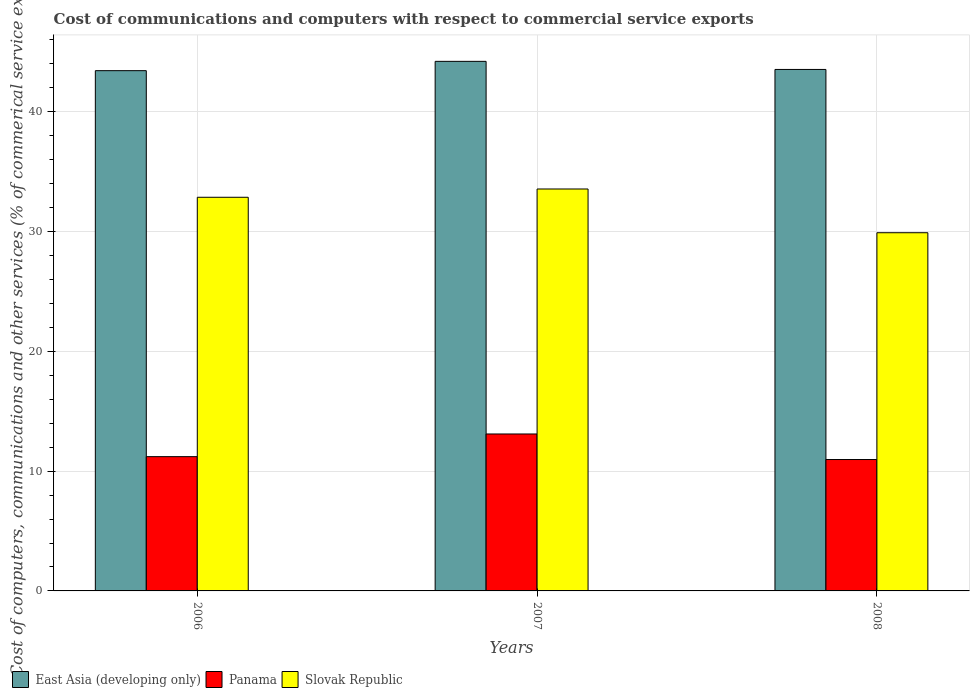Are the number of bars per tick equal to the number of legend labels?
Your answer should be compact. Yes. Are the number of bars on each tick of the X-axis equal?
Provide a short and direct response. Yes. How many bars are there on the 3rd tick from the left?
Provide a succinct answer. 3. In how many cases, is the number of bars for a given year not equal to the number of legend labels?
Give a very brief answer. 0. What is the cost of communications and computers in Panama in 2008?
Offer a terse response. 10.97. Across all years, what is the maximum cost of communications and computers in Panama?
Offer a very short reply. 13.1. Across all years, what is the minimum cost of communications and computers in East Asia (developing only)?
Provide a succinct answer. 43.43. What is the total cost of communications and computers in Slovak Republic in the graph?
Make the answer very short. 96.31. What is the difference between the cost of communications and computers in Slovak Republic in 2006 and that in 2008?
Ensure brevity in your answer.  2.96. What is the difference between the cost of communications and computers in Slovak Republic in 2007 and the cost of communications and computers in East Asia (developing only) in 2008?
Your response must be concise. -9.98. What is the average cost of communications and computers in East Asia (developing only) per year?
Offer a very short reply. 43.72. In the year 2007, what is the difference between the cost of communications and computers in Slovak Republic and cost of communications and computers in Panama?
Make the answer very short. 20.45. What is the ratio of the cost of communications and computers in East Asia (developing only) in 2006 to that in 2007?
Make the answer very short. 0.98. Is the cost of communications and computers in Panama in 2006 less than that in 2007?
Ensure brevity in your answer.  Yes. What is the difference between the highest and the second highest cost of communications and computers in East Asia (developing only)?
Offer a very short reply. 0.67. What is the difference between the highest and the lowest cost of communications and computers in Panama?
Offer a terse response. 2.13. What does the 3rd bar from the left in 2006 represents?
Provide a short and direct response. Slovak Republic. What does the 2nd bar from the right in 2008 represents?
Offer a terse response. Panama. How many bars are there?
Your answer should be very brief. 9. Are all the bars in the graph horizontal?
Ensure brevity in your answer.  No. How many years are there in the graph?
Your answer should be very brief. 3. What is the difference between two consecutive major ticks on the Y-axis?
Your response must be concise. 10. Where does the legend appear in the graph?
Provide a short and direct response. Bottom left. How many legend labels are there?
Keep it short and to the point. 3. How are the legend labels stacked?
Make the answer very short. Horizontal. What is the title of the graph?
Provide a short and direct response. Cost of communications and computers with respect to commercial service exports. What is the label or title of the Y-axis?
Your answer should be compact. Cost of computers, communications and other services (% of commerical service exports). What is the Cost of computers, communications and other services (% of commerical service exports) of East Asia (developing only) in 2006?
Your answer should be compact. 43.43. What is the Cost of computers, communications and other services (% of commerical service exports) in Panama in 2006?
Your answer should be very brief. 11.21. What is the Cost of computers, communications and other services (% of commerical service exports) in Slovak Republic in 2006?
Provide a succinct answer. 32.86. What is the Cost of computers, communications and other services (% of commerical service exports) of East Asia (developing only) in 2007?
Offer a very short reply. 44.21. What is the Cost of computers, communications and other services (% of commerical service exports) of Panama in 2007?
Your answer should be very brief. 13.1. What is the Cost of computers, communications and other services (% of commerical service exports) in Slovak Republic in 2007?
Your response must be concise. 33.55. What is the Cost of computers, communications and other services (% of commerical service exports) of East Asia (developing only) in 2008?
Ensure brevity in your answer.  43.53. What is the Cost of computers, communications and other services (% of commerical service exports) of Panama in 2008?
Offer a terse response. 10.97. What is the Cost of computers, communications and other services (% of commerical service exports) in Slovak Republic in 2008?
Your answer should be compact. 29.9. Across all years, what is the maximum Cost of computers, communications and other services (% of commerical service exports) in East Asia (developing only)?
Provide a short and direct response. 44.21. Across all years, what is the maximum Cost of computers, communications and other services (% of commerical service exports) in Panama?
Give a very brief answer. 13.1. Across all years, what is the maximum Cost of computers, communications and other services (% of commerical service exports) of Slovak Republic?
Provide a succinct answer. 33.55. Across all years, what is the minimum Cost of computers, communications and other services (% of commerical service exports) of East Asia (developing only)?
Give a very brief answer. 43.43. Across all years, what is the minimum Cost of computers, communications and other services (% of commerical service exports) in Panama?
Provide a short and direct response. 10.97. Across all years, what is the minimum Cost of computers, communications and other services (% of commerical service exports) of Slovak Republic?
Make the answer very short. 29.9. What is the total Cost of computers, communications and other services (% of commerical service exports) of East Asia (developing only) in the graph?
Make the answer very short. 131.16. What is the total Cost of computers, communications and other services (% of commerical service exports) of Panama in the graph?
Provide a short and direct response. 35.28. What is the total Cost of computers, communications and other services (% of commerical service exports) of Slovak Republic in the graph?
Your answer should be compact. 96.31. What is the difference between the Cost of computers, communications and other services (% of commerical service exports) in East Asia (developing only) in 2006 and that in 2007?
Offer a terse response. -0.78. What is the difference between the Cost of computers, communications and other services (% of commerical service exports) of Panama in 2006 and that in 2007?
Offer a very short reply. -1.89. What is the difference between the Cost of computers, communications and other services (% of commerical service exports) of Slovak Republic in 2006 and that in 2007?
Give a very brief answer. -0.69. What is the difference between the Cost of computers, communications and other services (% of commerical service exports) in East Asia (developing only) in 2006 and that in 2008?
Offer a very short reply. -0.1. What is the difference between the Cost of computers, communications and other services (% of commerical service exports) in Panama in 2006 and that in 2008?
Make the answer very short. 0.24. What is the difference between the Cost of computers, communications and other services (% of commerical service exports) in Slovak Republic in 2006 and that in 2008?
Provide a succinct answer. 2.96. What is the difference between the Cost of computers, communications and other services (% of commerical service exports) of East Asia (developing only) in 2007 and that in 2008?
Make the answer very short. 0.68. What is the difference between the Cost of computers, communications and other services (% of commerical service exports) of Panama in 2007 and that in 2008?
Provide a short and direct response. 2.13. What is the difference between the Cost of computers, communications and other services (% of commerical service exports) of Slovak Republic in 2007 and that in 2008?
Provide a succinct answer. 3.65. What is the difference between the Cost of computers, communications and other services (% of commerical service exports) of East Asia (developing only) in 2006 and the Cost of computers, communications and other services (% of commerical service exports) of Panama in 2007?
Provide a short and direct response. 30.33. What is the difference between the Cost of computers, communications and other services (% of commerical service exports) in East Asia (developing only) in 2006 and the Cost of computers, communications and other services (% of commerical service exports) in Slovak Republic in 2007?
Your answer should be compact. 9.88. What is the difference between the Cost of computers, communications and other services (% of commerical service exports) in Panama in 2006 and the Cost of computers, communications and other services (% of commerical service exports) in Slovak Republic in 2007?
Provide a short and direct response. -22.34. What is the difference between the Cost of computers, communications and other services (% of commerical service exports) in East Asia (developing only) in 2006 and the Cost of computers, communications and other services (% of commerical service exports) in Panama in 2008?
Give a very brief answer. 32.46. What is the difference between the Cost of computers, communications and other services (% of commerical service exports) in East Asia (developing only) in 2006 and the Cost of computers, communications and other services (% of commerical service exports) in Slovak Republic in 2008?
Your response must be concise. 13.53. What is the difference between the Cost of computers, communications and other services (% of commerical service exports) in Panama in 2006 and the Cost of computers, communications and other services (% of commerical service exports) in Slovak Republic in 2008?
Provide a succinct answer. -18.69. What is the difference between the Cost of computers, communications and other services (% of commerical service exports) in East Asia (developing only) in 2007 and the Cost of computers, communications and other services (% of commerical service exports) in Panama in 2008?
Offer a terse response. 33.24. What is the difference between the Cost of computers, communications and other services (% of commerical service exports) of East Asia (developing only) in 2007 and the Cost of computers, communications and other services (% of commerical service exports) of Slovak Republic in 2008?
Your response must be concise. 14.31. What is the difference between the Cost of computers, communications and other services (% of commerical service exports) in Panama in 2007 and the Cost of computers, communications and other services (% of commerical service exports) in Slovak Republic in 2008?
Provide a succinct answer. -16.8. What is the average Cost of computers, communications and other services (% of commerical service exports) of East Asia (developing only) per year?
Your answer should be very brief. 43.72. What is the average Cost of computers, communications and other services (% of commerical service exports) in Panama per year?
Your response must be concise. 11.76. What is the average Cost of computers, communications and other services (% of commerical service exports) in Slovak Republic per year?
Make the answer very short. 32.1. In the year 2006, what is the difference between the Cost of computers, communications and other services (% of commerical service exports) in East Asia (developing only) and Cost of computers, communications and other services (% of commerical service exports) in Panama?
Your answer should be very brief. 32.22. In the year 2006, what is the difference between the Cost of computers, communications and other services (% of commerical service exports) in East Asia (developing only) and Cost of computers, communications and other services (% of commerical service exports) in Slovak Republic?
Keep it short and to the point. 10.57. In the year 2006, what is the difference between the Cost of computers, communications and other services (% of commerical service exports) of Panama and Cost of computers, communications and other services (% of commerical service exports) of Slovak Republic?
Your response must be concise. -21.65. In the year 2007, what is the difference between the Cost of computers, communications and other services (% of commerical service exports) in East Asia (developing only) and Cost of computers, communications and other services (% of commerical service exports) in Panama?
Your response must be concise. 31.1. In the year 2007, what is the difference between the Cost of computers, communications and other services (% of commerical service exports) of East Asia (developing only) and Cost of computers, communications and other services (% of commerical service exports) of Slovak Republic?
Your answer should be very brief. 10.65. In the year 2007, what is the difference between the Cost of computers, communications and other services (% of commerical service exports) in Panama and Cost of computers, communications and other services (% of commerical service exports) in Slovak Republic?
Provide a succinct answer. -20.45. In the year 2008, what is the difference between the Cost of computers, communications and other services (% of commerical service exports) of East Asia (developing only) and Cost of computers, communications and other services (% of commerical service exports) of Panama?
Ensure brevity in your answer.  32.56. In the year 2008, what is the difference between the Cost of computers, communications and other services (% of commerical service exports) of East Asia (developing only) and Cost of computers, communications and other services (% of commerical service exports) of Slovak Republic?
Provide a succinct answer. 13.63. In the year 2008, what is the difference between the Cost of computers, communications and other services (% of commerical service exports) of Panama and Cost of computers, communications and other services (% of commerical service exports) of Slovak Republic?
Your response must be concise. -18.93. What is the ratio of the Cost of computers, communications and other services (% of commerical service exports) in East Asia (developing only) in 2006 to that in 2007?
Ensure brevity in your answer.  0.98. What is the ratio of the Cost of computers, communications and other services (% of commerical service exports) in Panama in 2006 to that in 2007?
Your answer should be compact. 0.86. What is the ratio of the Cost of computers, communications and other services (% of commerical service exports) of Slovak Republic in 2006 to that in 2007?
Ensure brevity in your answer.  0.98. What is the ratio of the Cost of computers, communications and other services (% of commerical service exports) in East Asia (developing only) in 2006 to that in 2008?
Your answer should be compact. 1. What is the ratio of the Cost of computers, communications and other services (% of commerical service exports) in Panama in 2006 to that in 2008?
Give a very brief answer. 1.02. What is the ratio of the Cost of computers, communications and other services (% of commerical service exports) of Slovak Republic in 2006 to that in 2008?
Ensure brevity in your answer.  1.1. What is the ratio of the Cost of computers, communications and other services (% of commerical service exports) of East Asia (developing only) in 2007 to that in 2008?
Ensure brevity in your answer.  1.02. What is the ratio of the Cost of computers, communications and other services (% of commerical service exports) in Panama in 2007 to that in 2008?
Provide a succinct answer. 1.19. What is the ratio of the Cost of computers, communications and other services (% of commerical service exports) of Slovak Republic in 2007 to that in 2008?
Provide a short and direct response. 1.12. What is the difference between the highest and the second highest Cost of computers, communications and other services (% of commerical service exports) in East Asia (developing only)?
Your response must be concise. 0.68. What is the difference between the highest and the second highest Cost of computers, communications and other services (% of commerical service exports) of Panama?
Offer a very short reply. 1.89. What is the difference between the highest and the second highest Cost of computers, communications and other services (% of commerical service exports) in Slovak Republic?
Provide a succinct answer. 0.69. What is the difference between the highest and the lowest Cost of computers, communications and other services (% of commerical service exports) in East Asia (developing only)?
Give a very brief answer. 0.78. What is the difference between the highest and the lowest Cost of computers, communications and other services (% of commerical service exports) of Panama?
Make the answer very short. 2.13. What is the difference between the highest and the lowest Cost of computers, communications and other services (% of commerical service exports) in Slovak Republic?
Provide a short and direct response. 3.65. 